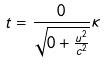<formula> <loc_0><loc_0><loc_500><loc_500>t = \frac { 0 } { \sqrt { 0 + \frac { u ^ { 2 } } { c ^ { 2 } } } } \kappa</formula> 